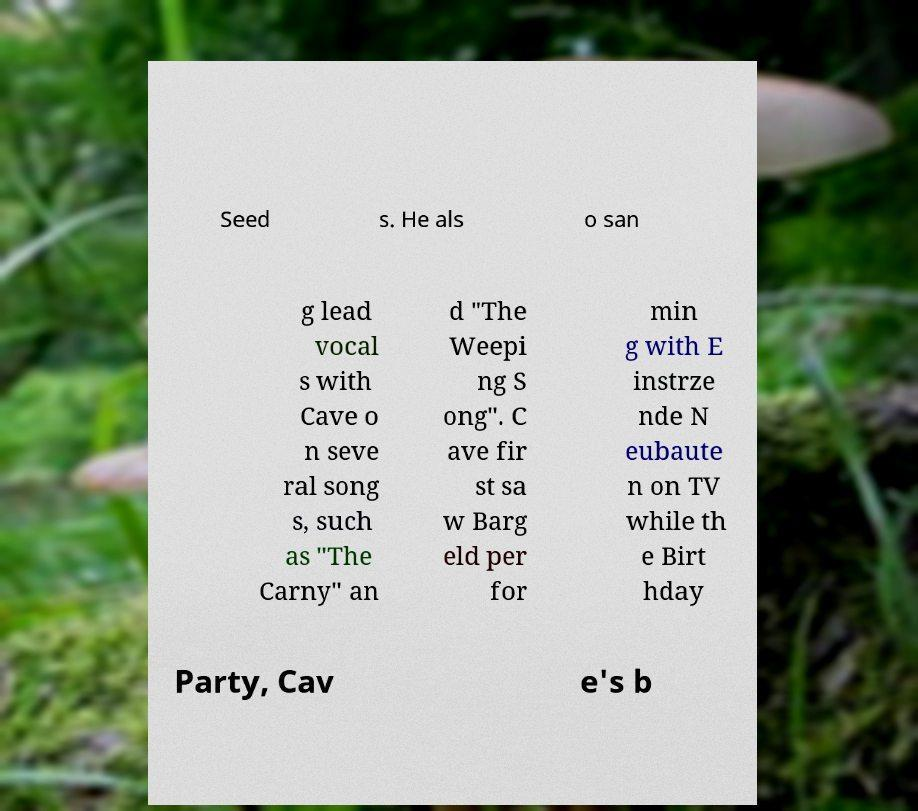Please identify and transcribe the text found in this image. Seed s. He als o san g lead vocal s with Cave o n seve ral song s, such as "The Carny" an d "The Weepi ng S ong". C ave fir st sa w Barg eld per for min g with E instrze nde N eubaute n on TV while th e Birt hday Party, Cav e's b 